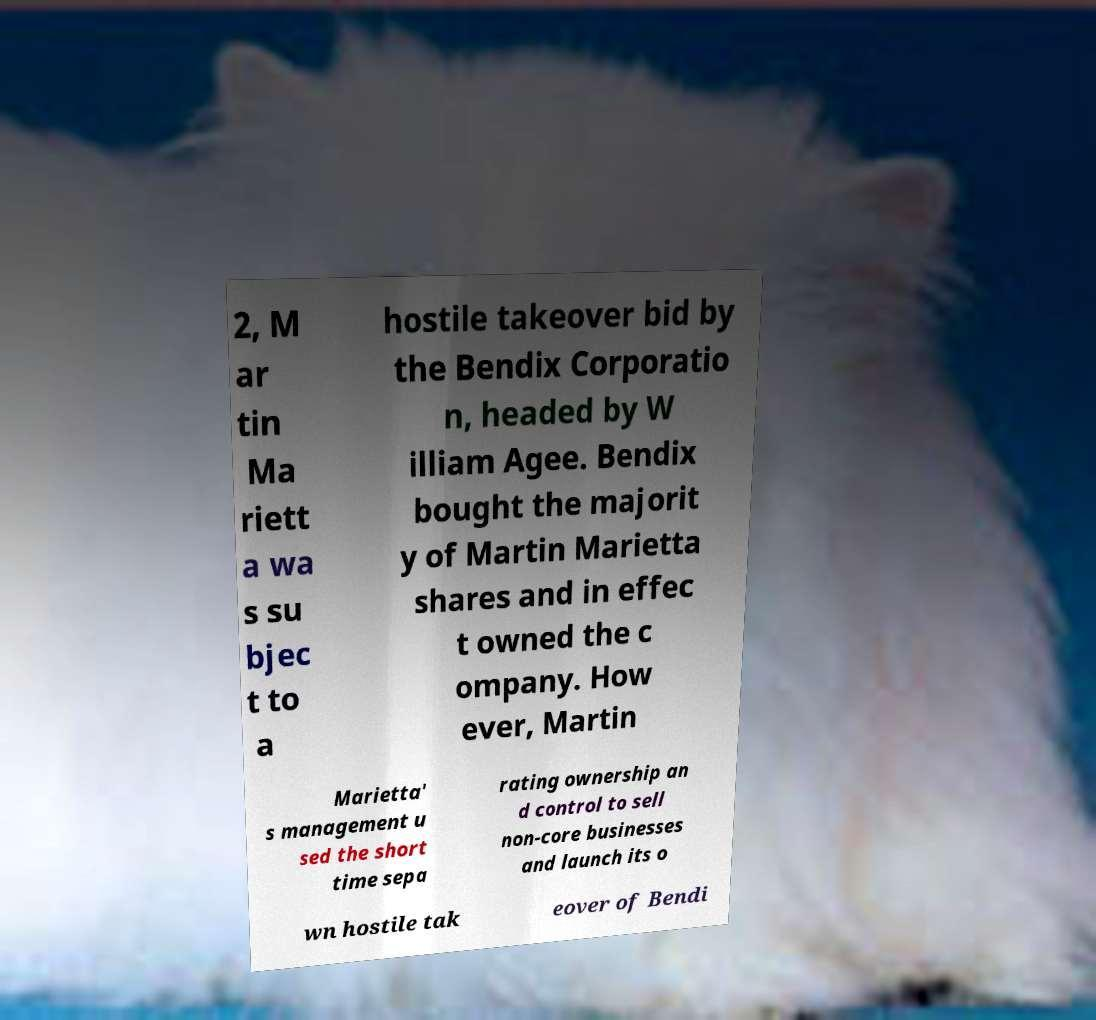Could you assist in decoding the text presented in this image and type it out clearly? 2, M ar tin Ma riett a wa s su bjec t to a hostile takeover bid by the Bendix Corporatio n, headed by W illiam Agee. Bendix bought the majorit y of Martin Marietta shares and in effec t owned the c ompany. How ever, Martin Marietta' s management u sed the short time sepa rating ownership an d control to sell non-core businesses and launch its o wn hostile tak eover of Bendi 